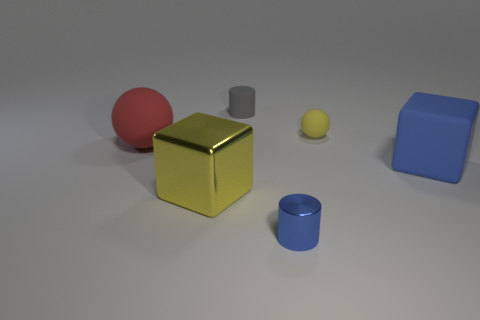There is a ball that is the same size as the yellow metallic object; what is it made of?
Offer a terse response. Rubber. There is a metal cylinder; is it the same color as the tiny cylinder behind the red matte thing?
Give a very brief answer. No. Are there fewer large blocks behind the red matte sphere than rubber cylinders?
Give a very brief answer. Yes. What number of tiny green objects are there?
Your response must be concise. 0. There is a large matte thing to the right of the tiny cylinder that is to the left of the small metallic thing; what is its shape?
Your answer should be very brief. Cube. How many cubes are to the right of the metal cylinder?
Your answer should be compact. 1. Are the big yellow object and the large thing on the right side of the yellow block made of the same material?
Offer a terse response. No. Is there a gray cylinder of the same size as the gray matte object?
Offer a very short reply. No. Is the number of tiny metallic objects that are behind the big blue object the same as the number of large yellow cubes?
Make the answer very short. No. What is the size of the blue metal cylinder?
Offer a very short reply. Small. 